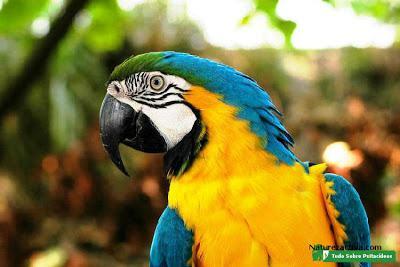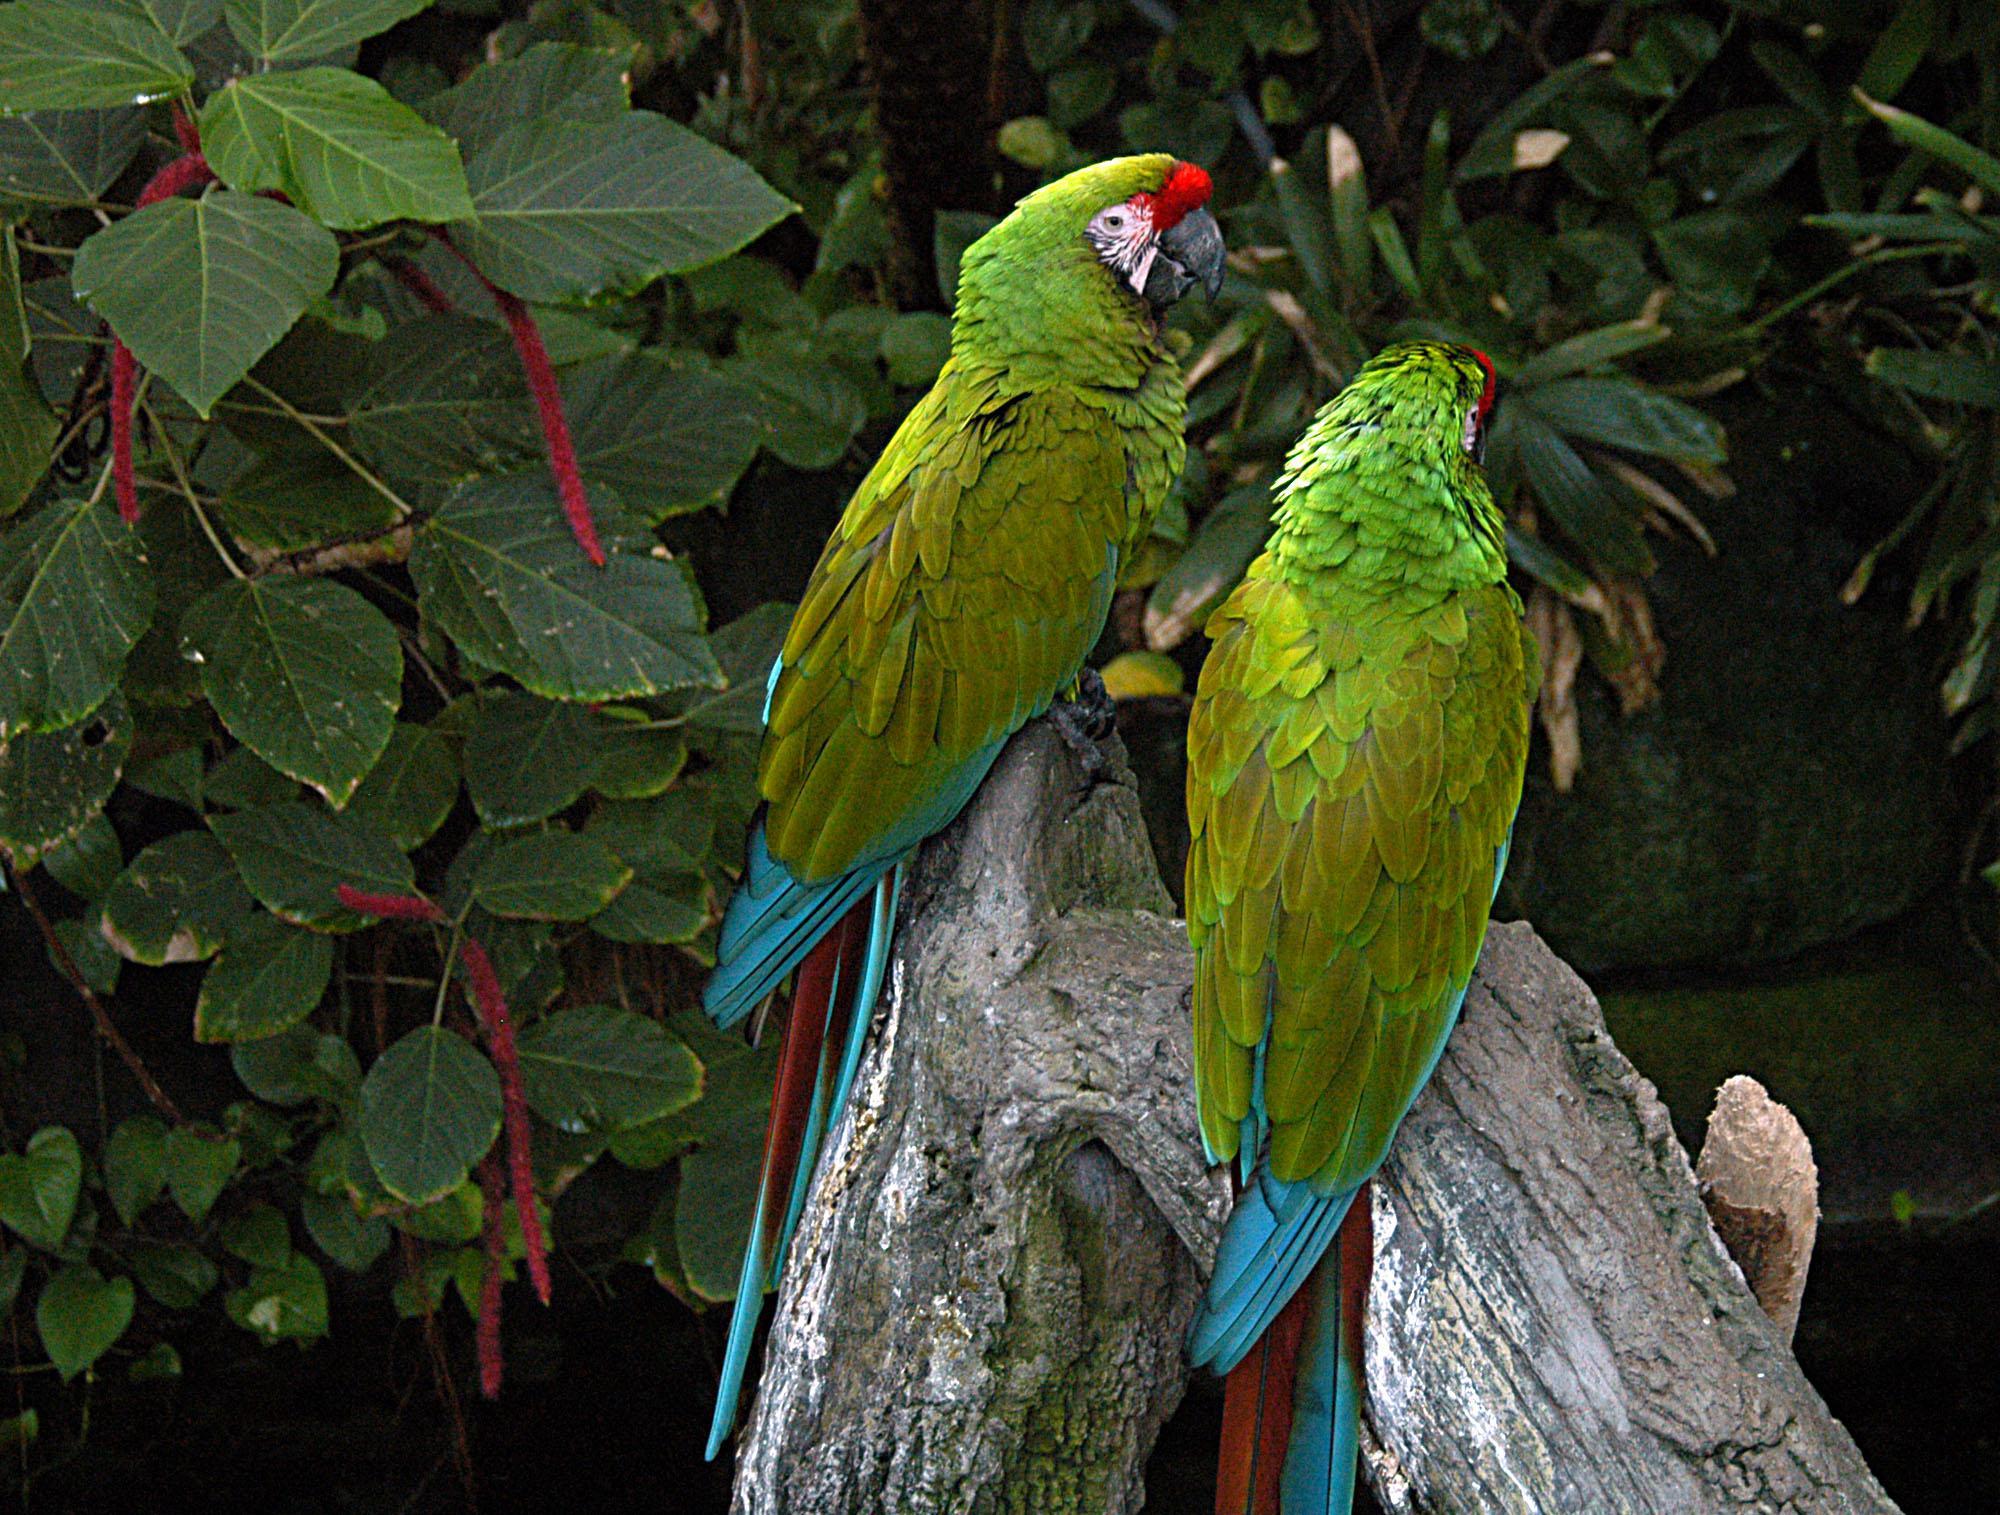The first image is the image on the left, the second image is the image on the right. Evaluate the accuracy of this statement regarding the images: "In one image two parrots are standing on a branch and in the other there's only one parrot". Is it true? Answer yes or no. Yes. The first image is the image on the left, the second image is the image on the right. For the images displayed, is the sentence "There are at most 3 parrots." factually correct? Answer yes or no. Yes. 